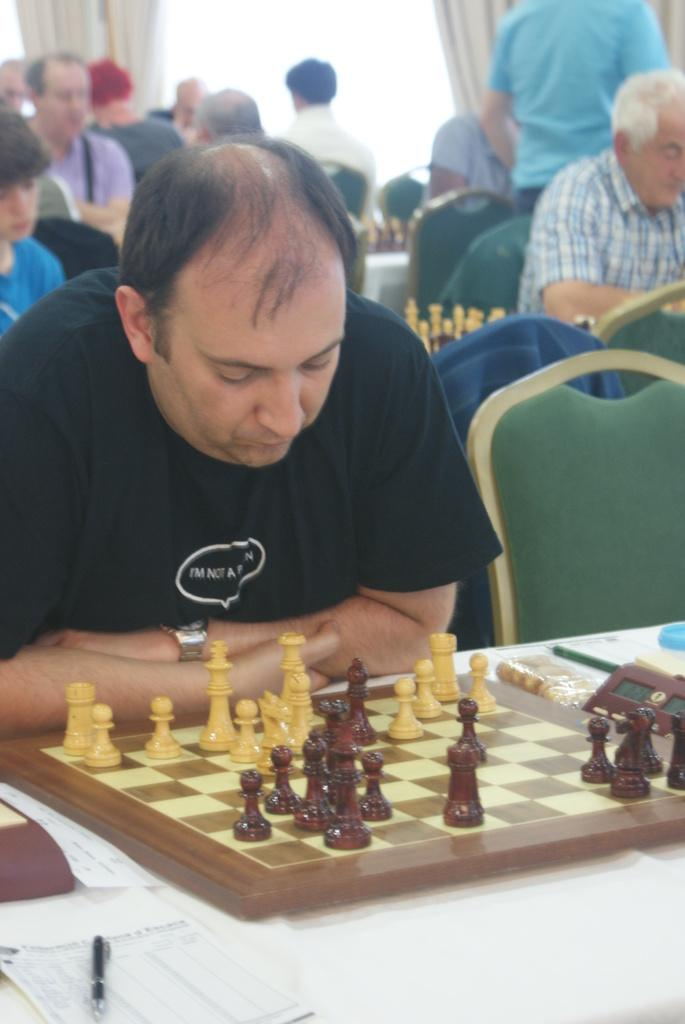What are the people in the image doing? The persons in the image are sitting on chairs. Is there anyone standing in the image? Yes, there is a person standing in the image. What is on the table in the image? There is a chess board, a paper, a pen, and other unspecified things on the table. What can be seen in the background of the image? There is a curtain in the background. What type of dinosaurs can be seen in the image? There are no dinosaurs present in the image. How does the person standing in the image manage to get the attention of the others? The image does not provide information about how the person standing might get the attention of the others. 